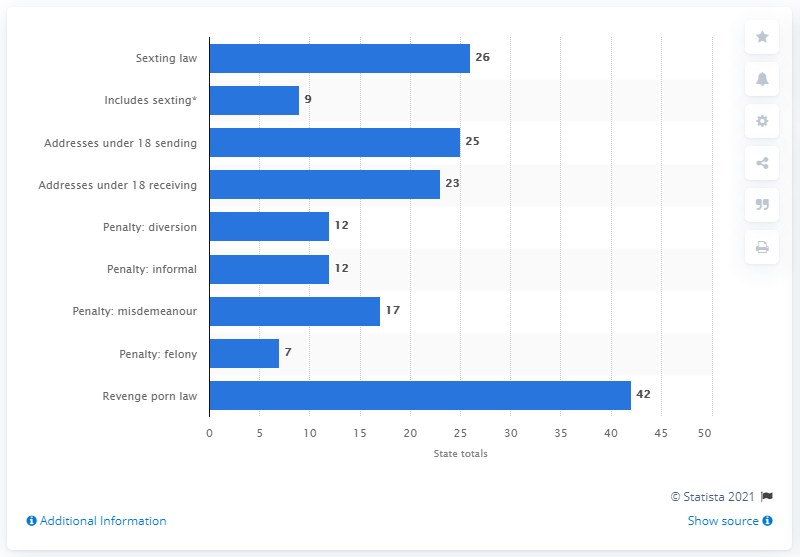Highlight a few significant elements in this photo. As of July 2019, nine states had laws regarding sexting. 